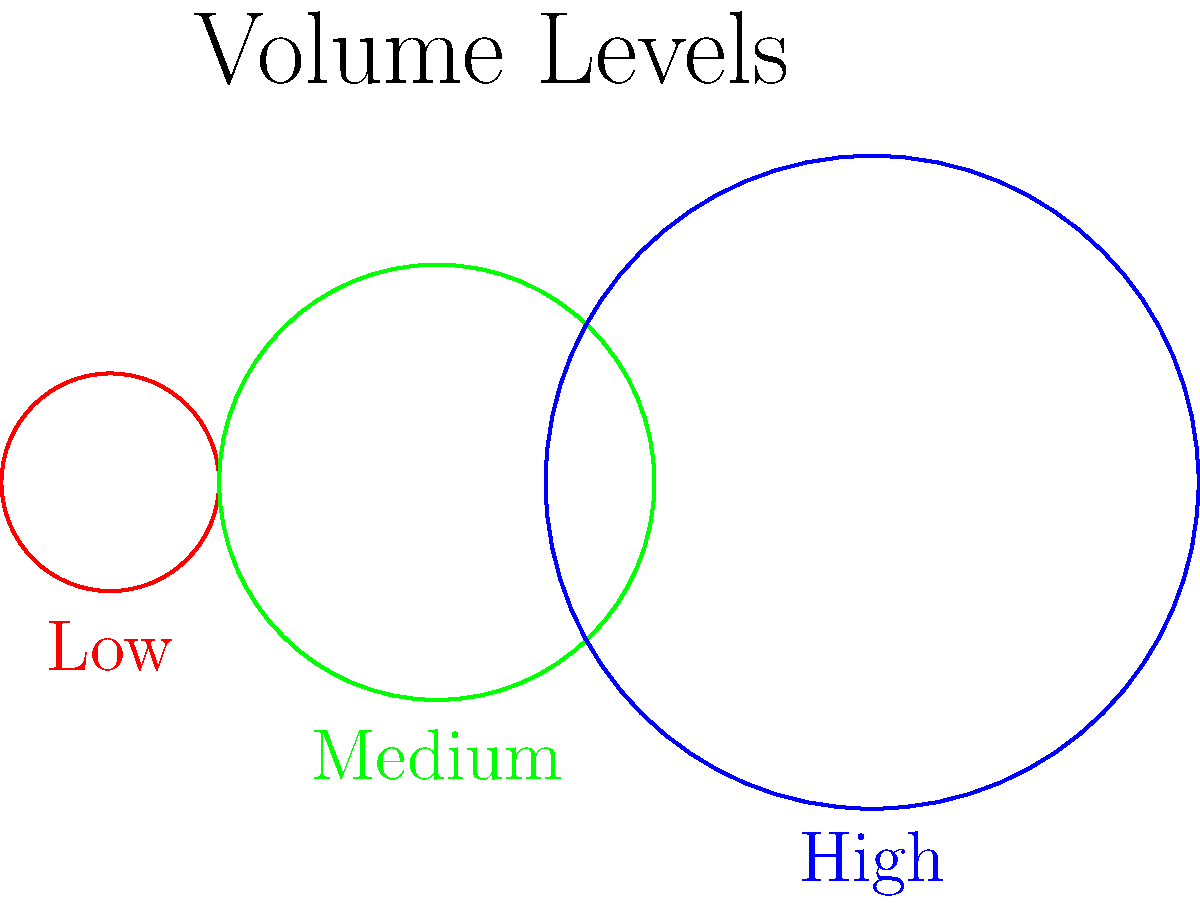Looking at the image of three circles representing volume levels on your Spotify player, which color represents the highest volume for your relaxation music? Let's analyze the image step-by-step:

1. We see three circles of different sizes and colors.
2. The smallest circle is red and labeled "Low".
3. The medium-sized circle is green and labeled "Medium".
4. The largest circle is blue and labeled "High".
5. In general, larger sizes often represent higher values or intensities.
6. For volume representation, a larger circle typically indicates a higher volume level.
7. The blue circle is the largest among the three.
8. Therefore, the blue circle represents the highest volume level for your relaxation music on Spotify.
Answer: Blue 